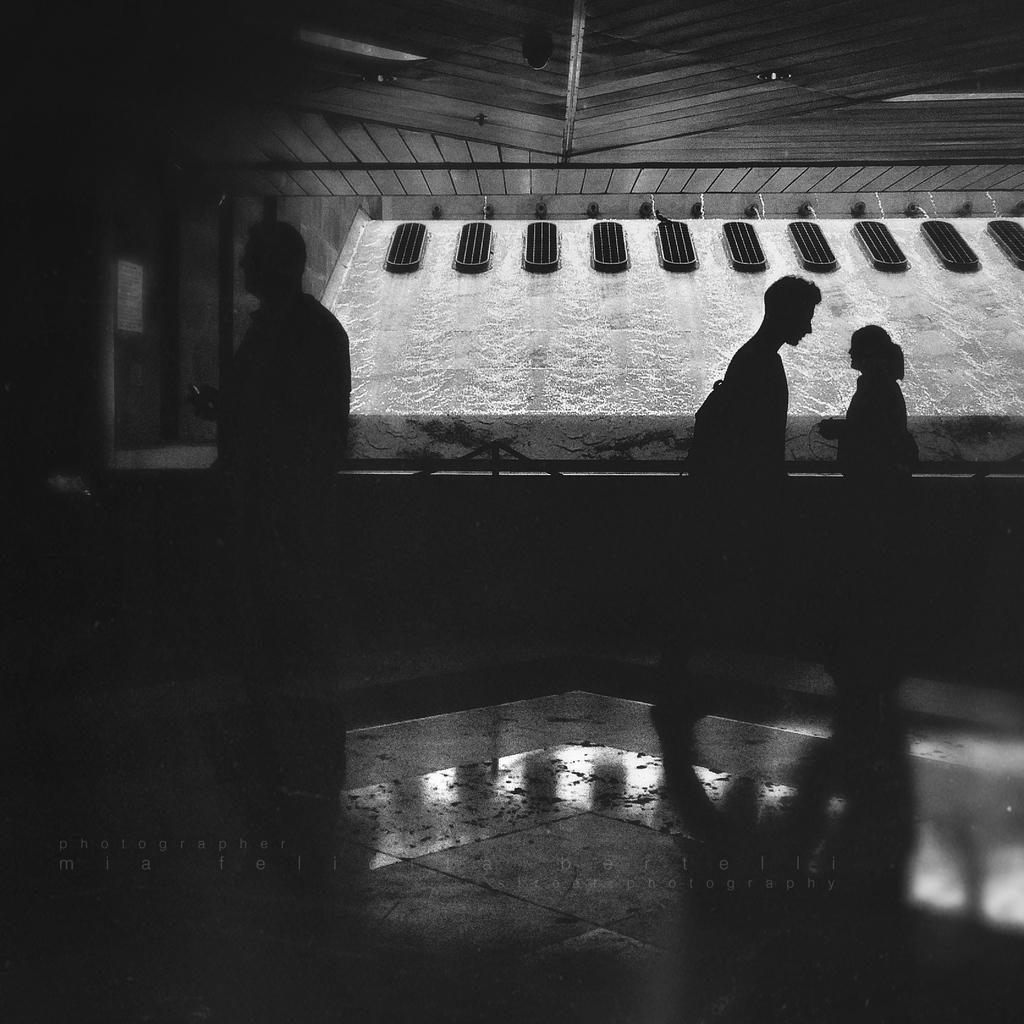Describe this image in one or two sentences. In this black and white image, we can see three persons on the floor. There is an object in the middle of the image. 